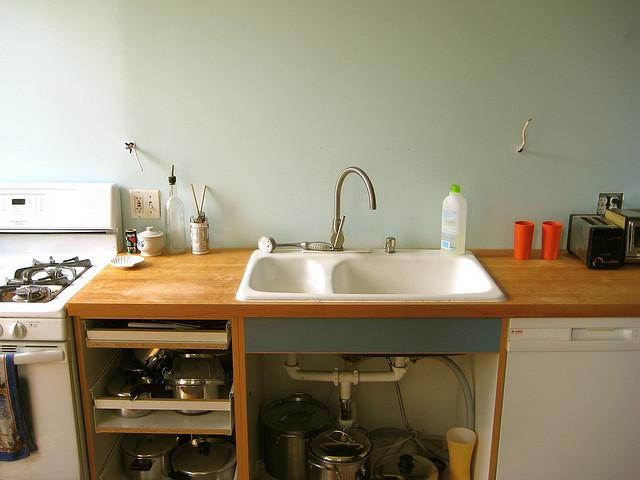What would someone most likely clean in this room? Please explain your reasoning. dishes. The room has dishes. 